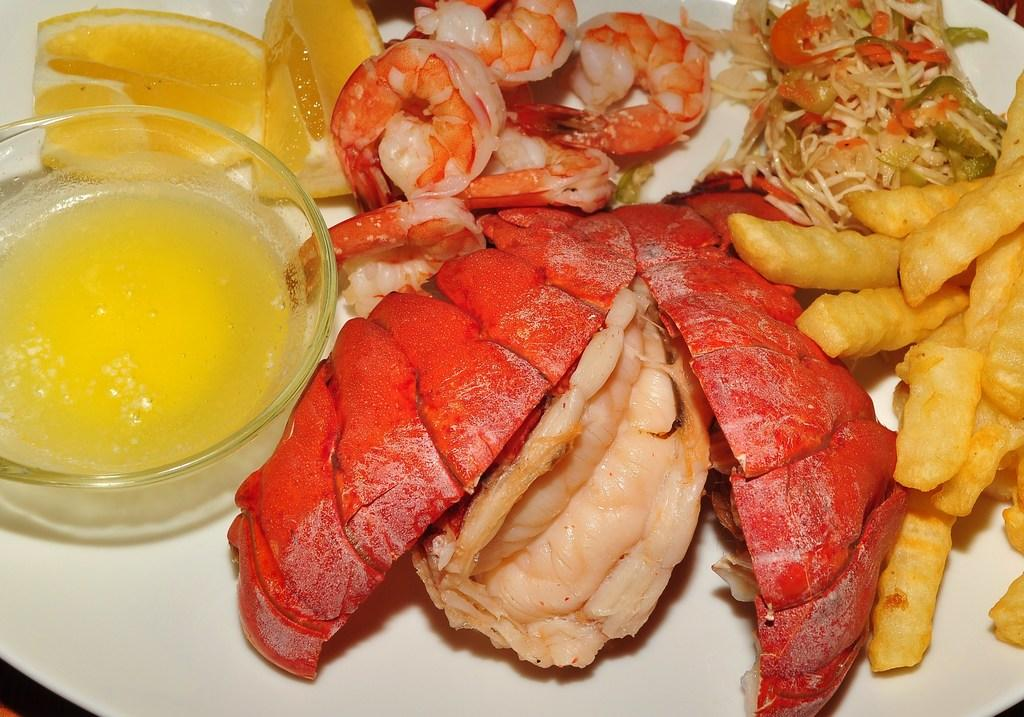What type of food can be seen in the image? The food in the image has red, cream, and yellow colors. How is the food arranged in the image? The food is in a plate in the image. What is the color of the plate? The plate is white. What other object is present in the plate? There is a glass bowl in the plate. Can you see the detail of the footprint in the food? There is no footprint visible in the food or the image. 